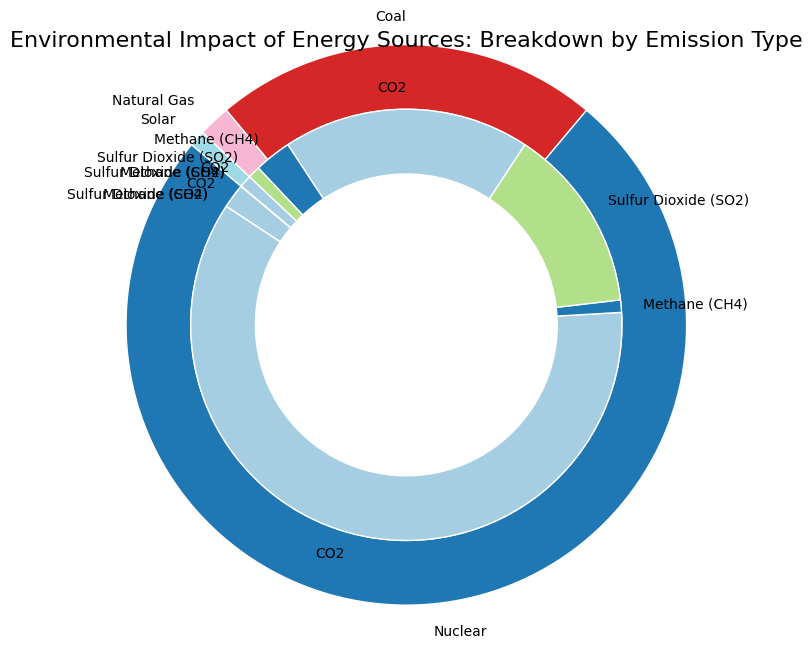Which energy source contributes the most to CO2 emissions? Examine the wedges labeled with each energy source and look for the largest wedge in the inner ring corresponding to CO2 emissions. You will see that the wedge for CO2 emissions is the largest for Coal.
Answer: Coal Which emission type has the smallest contribution for Nuclear energy? Find the section of the inner pie chart corresponding to Nuclear, then compare the relative sizes of the wedges representing the different emission types. The wedges for Methane (CH4) and Sulfur Dioxide (SO2) are both zero.
Answer: Methane (CH4) and Sulfur Dioxide (SO2) How does the total percentage of CO2 emissions from Natural Gas compare to Nuclear? Look at the wedges in the inner ring corresponding to CO2 for both Natural Gas and Nuclear. The Natural Gas wedge is significantly larger than the Nuclear one. Natural Gas has 20% CO2 emissions and Nuclear has 2%.
Answer: Natural Gas has more CO2 emissions than Nuclear Combining all emission types, how do the total emissions of Coal compare to Nuclear? Sum the percentage values for all emission types for Coal (65 + 1 + 15 = 81) and compare it with the sum for Nuclear (2 + 0 + 0 = 2). Coal has significantly higher total emissions.
Answer: Coal has higher total emissions than Nuclear What is the combined contribution of Methane (CH4) emissions from Coal and Natural Gas? Add the values of Methane (CH4) emissions from Coal (1%) and Natural Gas (3%). The combined Methane emissions from these sources are 1 + 3 = 4%.
Answer: 4% How does the percentage of Sulfur Dioxide (SO2) emissions from Coal compare to Natural Gas? Examine the inner pie wedges for CO2 emissions for both Coal and Natural Gas. The wedge for Sulfur Dioxide emissions from Coal (15%) is larger than that from Natural Gas (1%).
Answer: Coal has more Sulfur Dioxide emissions than Natural Gas What is the percentage difference in CO2 emissions between Solar and Nuclear? Find the wedges for CO2 emissions for Solar (1%) and Nuclear (2%), then calculate the percentage difference: 2% - 1% = 1%.
Answer: 1% Which energy source has the smallest total environmental impact by percentage? Sum the percentage values for all emission types for all energy sources and determine which total is the smallest. Solar has the smallest total: 1%.
Answer: Solar How does the total percentage of emissions from Solar compare to Natural Gas for all emission types? Sum the percentage values for each emission type for Solar (1% total) and compare it to the total for Natural Gas (20 + 3 + 1 = 24).
Answer: Solar emits much less compared to Natural Gas 